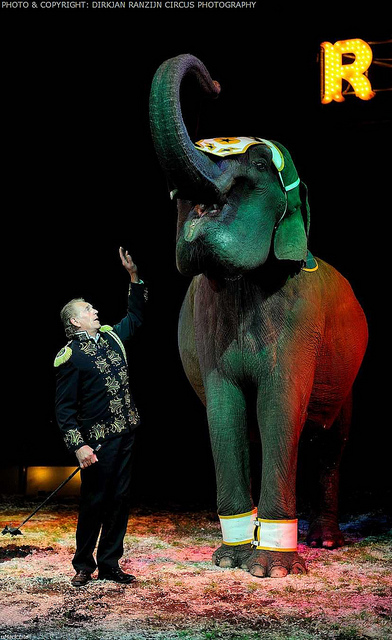Please transcribe the text in this image. R PHOTO COPYRIGHT DIRKJAN RANZIJN CIRCUS 8 PHOTOGRAPHY 